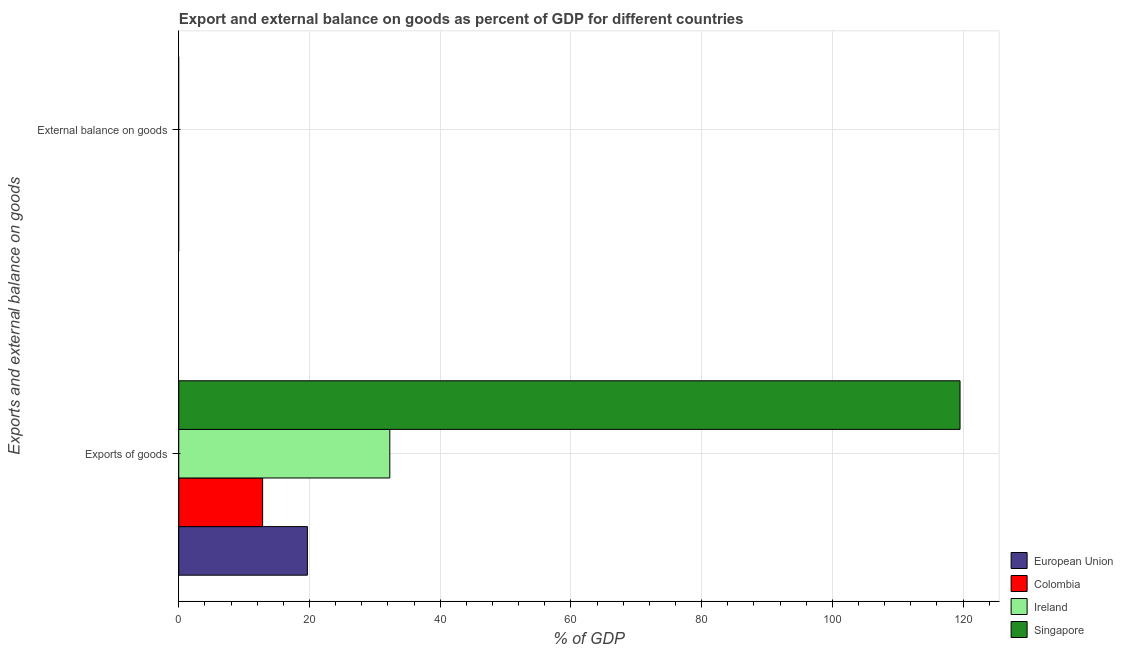Are the number of bars per tick equal to the number of legend labels?
Your answer should be compact. No. How many bars are there on the 2nd tick from the top?
Your response must be concise. 4. What is the label of the 2nd group of bars from the top?
Provide a succinct answer. Exports of goods. What is the export of goods as percentage of gdp in Colombia?
Offer a very short reply. 12.83. Across all countries, what is the maximum export of goods as percentage of gdp?
Provide a short and direct response. 119.53. In which country was the export of goods as percentage of gdp maximum?
Your response must be concise. Singapore. What is the total external balance on goods as percentage of gdp in the graph?
Give a very brief answer. 0. What is the difference between the export of goods as percentage of gdp in Singapore and that in Ireland?
Your response must be concise. 87.24. What is the difference between the external balance on goods as percentage of gdp in Singapore and the export of goods as percentage of gdp in Ireland?
Offer a terse response. -32.29. In how many countries, is the export of goods as percentage of gdp greater than 48 %?
Your response must be concise. 1. What is the ratio of the export of goods as percentage of gdp in Colombia to that in Ireland?
Make the answer very short. 0.4. Is the export of goods as percentage of gdp in Singapore less than that in European Union?
Offer a terse response. No. In how many countries, is the export of goods as percentage of gdp greater than the average export of goods as percentage of gdp taken over all countries?
Ensure brevity in your answer.  1. Does the graph contain grids?
Keep it short and to the point. Yes. Where does the legend appear in the graph?
Ensure brevity in your answer.  Bottom right. How many legend labels are there?
Your answer should be compact. 4. How are the legend labels stacked?
Make the answer very short. Vertical. What is the title of the graph?
Ensure brevity in your answer.  Export and external balance on goods as percent of GDP for different countries. Does "Benin" appear as one of the legend labels in the graph?
Your response must be concise. No. What is the label or title of the X-axis?
Your answer should be compact. % of GDP. What is the label or title of the Y-axis?
Ensure brevity in your answer.  Exports and external balance on goods. What is the % of GDP of European Union in Exports of goods?
Your response must be concise. 19.68. What is the % of GDP of Colombia in Exports of goods?
Keep it short and to the point. 12.83. What is the % of GDP of Ireland in Exports of goods?
Your answer should be very brief. 32.29. What is the % of GDP of Singapore in Exports of goods?
Your answer should be very brief. 119.53. What is the % of GDP in Colombia in External balance on goods?
Ensure brevity in your answer.  0. What is the % of GDP of Singapore in External balance on goods?
Give a very brief answer. 0. Across all Exports and external balance on goods, what is the maximum % of GDP in European Union?
Give a very brief answer. 19.68. Across all Exports and external balance on goods, what is the maximum % of GDP of Colombia?
Offer a very short reply. 12.83. Across all Exports and external balance on goods, what is the maximum % of GDP of Ireland?
Offer a terse response. 32.29. Across all Exports and external balance on goods, what is the maximum % of GDP in Singapore?
Provide a succinct answer. 119.53. Across all Exports and external balance on goods, what is the minimum % of GDP in European Union?
Your response must be concise. 0. Across all Exports and external balance on goods, what is the minimum % of GDP of Ireland?
Provide a short and direct response. 0. What is the total % of GDP in European Union in the graph?
Ensure brevity in your answer.  19.68. What is the total % of GDP in Colombia in the graph?
Your answer should be very brief. 12.83. What is the total % of GDP in Ireland in the graph?
Provide a succinct answer. 32.29. What is the total % of GDP of Singapore in the graph?
Offer a very short reply. 119.53. What is the average % of GDP of European Union per Exports and external balance on goods?
Ensure brevity in your answer.  9.84. What is the average % of GDP of Colombia per Exports and external balance on goods?
Offer a terse response. 6.41. What is the average % of GDP of Ireland per Exports and external balance on goods?
Offer a very short reply. 16.14. What is the average % of GDP in Singapore per Exports and external balance on goods?
Ensure brevity in your answer.  59.76. What is the difference between the % of GDP in European Union and % of GDP in Colombia in Exports of goods?
Offer a terse response. 6.85. What is the difference between the % of GDP in European Union and % of GDP in Ireland in Exports of goods?
Ensure brevity in your answer.  -12.61. What is the difference between the % of GDP of European Union and % of GDP of Singapore in Exports of goods?
Offer a terse response. -99.85. What is the difference between the % of GDP in Colombia and % of GDP in Ireland in Exports of goods?
Your answer should be compact. -19.46. What is the difference between the % of GDP of Colombia and % of GDP of Singapore in Exports of goods?
Provide a succinct answer. -106.7. What is the difference between the % of GDP in Ireland and % of GDP in Singapore in Exports of goods?
Provide a succinct answer. -87.24. What is the difference between the highest and the lowest % of GDP in European Union?
Ensure brevity in your answer.  19.68. What is the difference between the highest and the lowest % of GDP in Colombia?
Make the answer very short. 12.83. What is the difference between the highest and the lowest % of GDP of Ireland?
Keep it short and to the point. 32.29. What is the difference between the highest and the lowest % of GDP of Singapore?
Keep it short and to the point. 119.53. 